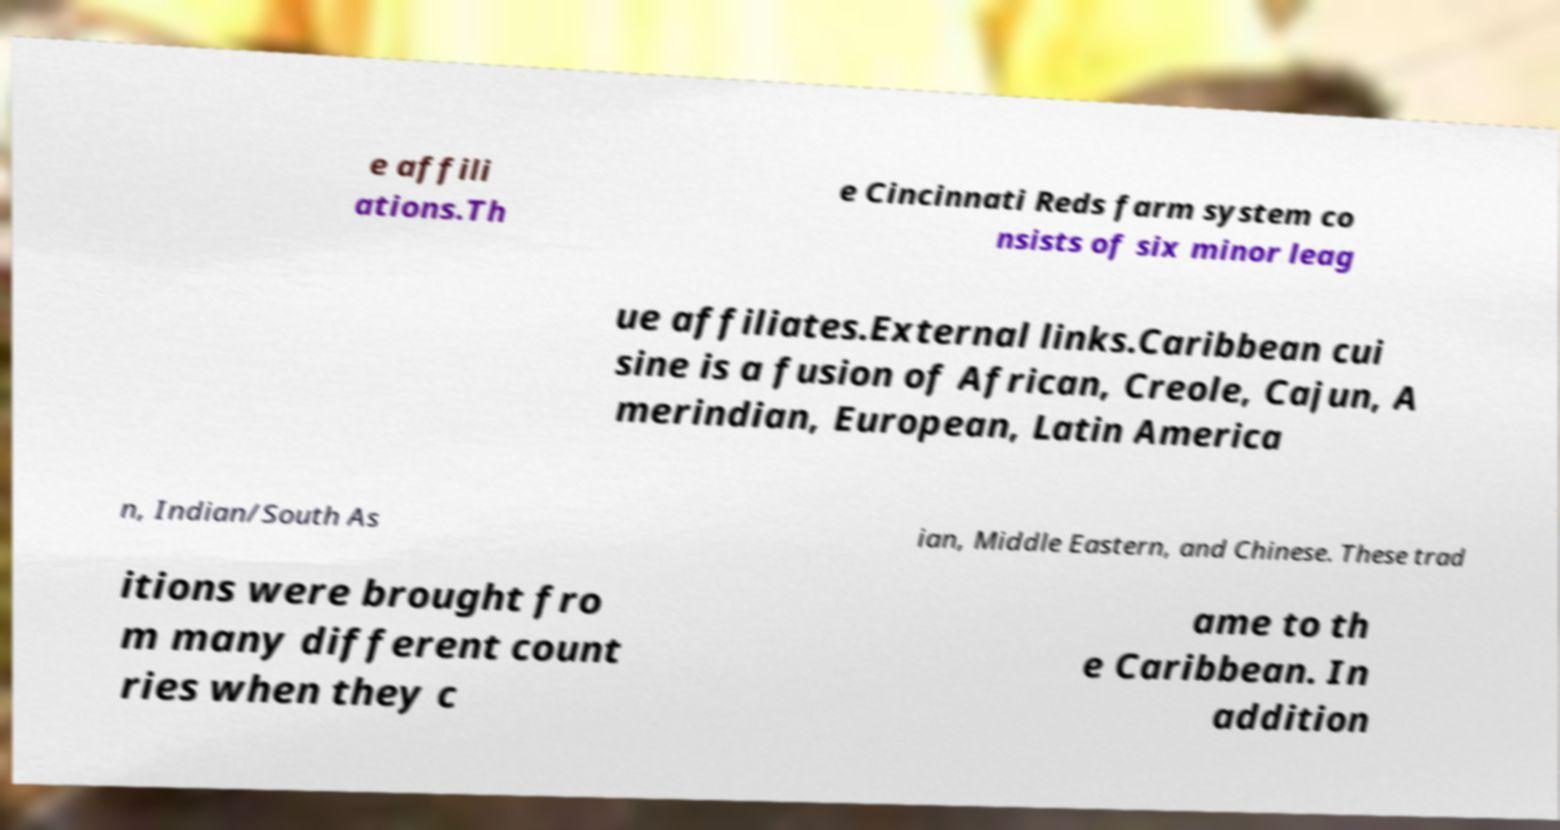Could you assist in decoding the text presented in this image and type it out clearly? e affili ations.Th e Cincinnati Reds farm system co nsists of six minor leag ue affiliates.External links.Caribbean cui sine is a fusion of African, Creole, Cajun, A merindian, European, Latin America n, Indian/South As ian, Middle Eastern, and Chinese. These trad itions were brought fro m many different count ries when they c ame to th e Caribbean. In addition 